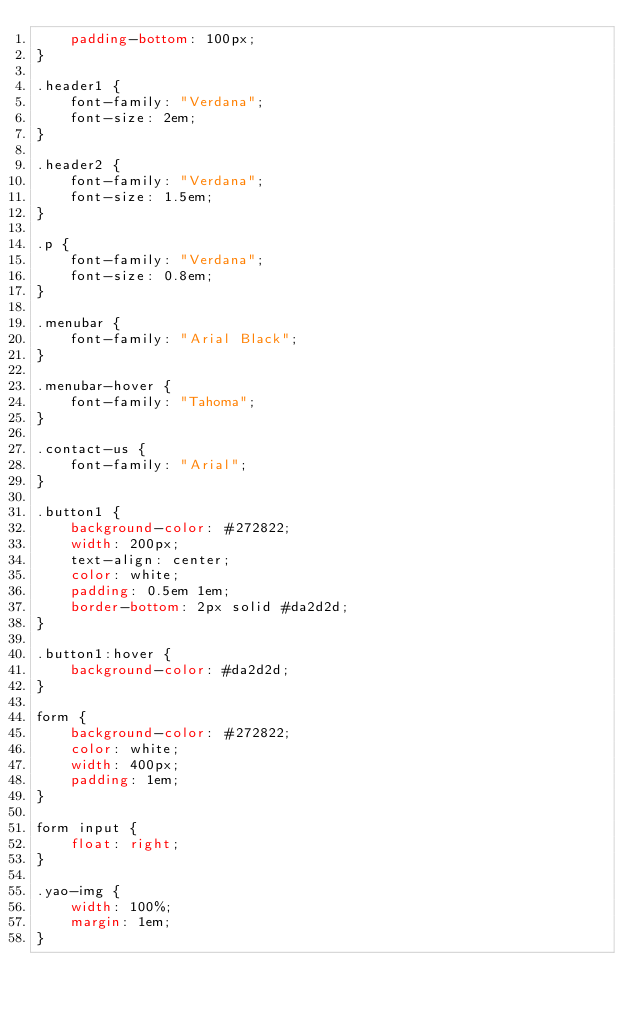Convert code to text. <code><loc_0><loc_0><loc_500><loc_500><_CSS_>    padding-bottom: 100px;
}

.header1 {
    font-family: "Verdana";
    font-size: 2em;
}

.header2 {
    font-family: "Verdana";
    font-size: 1.5em;
}

.p {
    font-family: "Verdana";
    font-size: 0.8em;
}

.menubar {
    font-family: "Arial Black";
}

.menubar-hover {
    font-family: "Tahoma";
}

.contact-us {
    font-family: "Arial";
}

.button1 {
    background-color: #272822;
    width: 200px;
    text-align: center;
    color: white;
    padding: 0.5em 1em;
    border-bottom: 2px solid #da2d2d;
}

.button1:hover {
    background-color: #da2d2d;
}

form {
    background-color: #272822;
    color: white;
    width: 400px;
    padding: 1em;
}

form input {
    float: right;
}

.yao-img {
    width: 100%;
    margin: 1em;
}
</code> 